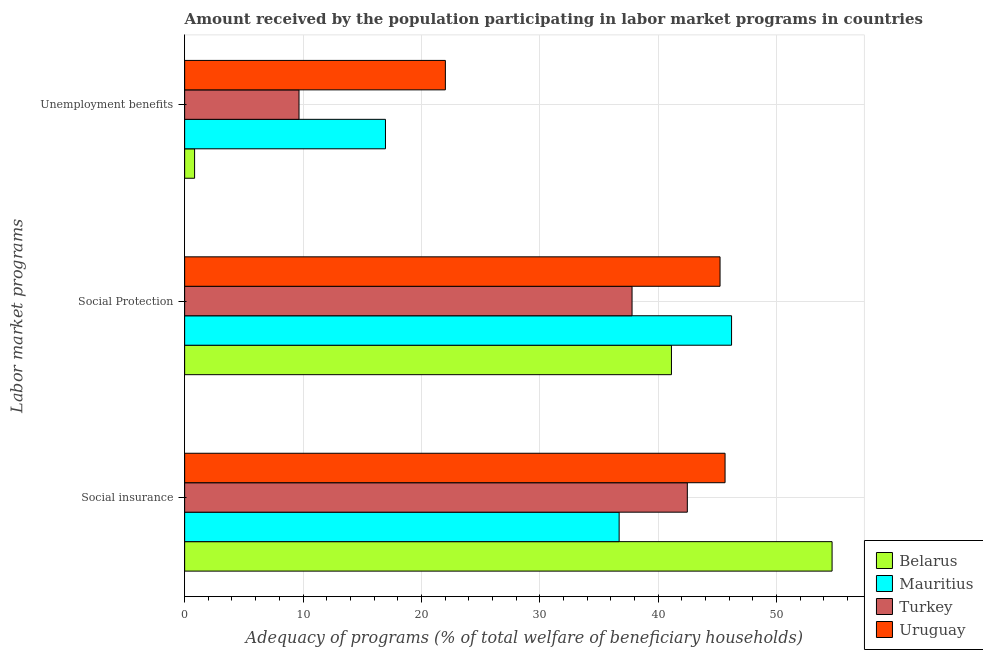How many different coloured bars are there?
Provide a short and direct response. 4. How many groups of bars are there?
Offer a terse response. 3. How many bars are there on the 3rd tick from the top?
Provide a short and direct response. 4. How many bars are there on the 3rd tick from the bottom?
Provide a short and direct response. 4. What is the label of the 3rd group of bars from the top?
Offer a very short reply. Social insurance. What is the amount received by the population participating in social protection programs in Turkey?
Give a very brief answer. 37.8. Across all countries, what is the maximum amount received by the population participating in unemployment benefits programs?
Your answer should be very brief. 22.03. Across all countries, what is the minimum amount received by the population participating in unemployment benefits programs?
Provide a short and direct response. 0.84. In which country was the amount received by the population participating in social insurance programs maximum?
Your response must be concise. Belarus. In which country was the amount received by the population participating in social insurance programs minimum?
Offer a terse response. Mauritius. What is the total amount received by the population participating in unemployment benefits programs in the graph?
Ensure brevity in your answer.  49.5. What is the difference between the amount received by the population participating in social insurance programs in Uruguay and that in Mauritius?
Provide a short and direct response. 8.95. What is the difference between the amount received by the population participating in social protection programs in Mauritius and the amount received by the population participating in unemployment benefits programs in Turkey?
Make the answer very short. 36.54. What is the average amount received by the population participating in social protection programs per country?
Make the answer very short. 42.59. What is the difference between the amount received by the population participating in social insurance programs and amount received by the population participating in unemployment benefits programs in Belarus?
Keep it short and to the point. 53.86. What is the ratio of the amount received by the population participating in social insurance programs in Turkey to that in Uruguay?
Make the answer very short. 0.93. Is the amount received by the population participating in unemployment benefits programs in Uruguay less than that in Turkey?
Your response must be concise. No. What is the difference between the highest and the second highest amount received by the population participating in social protection programs?
Provide a short and direct response. 0.97. What is the difference between the highest and the lowest amount received by the population participating in social protection programs?
Keep it short and to the point. 8.41. Is the sum of the amount received by the population participating in social insurance programs in Turkey and Uruguay greater than the maximum amount received by the population participating in social protection programs across all countries?
Offer a very short reply. Yes. What does the 1st bar from the top in Unemployment benefits represents?
Ensure brevity in your answer.  Uruguay. What does the 4th bar from the bottom in Social insurance represents?
Make the answer very short. Uruguay. Is it the case that in every country, the sum of the amount received by the population participating in social insurance programs and amount received by the population participating in social protection programs is greater than the amount received by the population participating in unemployment benefits programs?
Your answer should be very brief. Yes. What is the difference between two consecutive major ticks on the X-axis?
Your response must be concise. 10. Does the graph contain any zero values?
Provide a succinct answer. No. How are the legend labels stacked?
Offer a very short reply. Vertical. What is the title of the graph?
Make the answer very short. Amount received by the population participating in labor market programs in countries. Does "Armenia" appear as one of the legend labels in the graph?
Ensure brevity in your answer.  No. What is the label or title of the X-axis?
Your answer should be compact. Adequacy of programs (% of total welfare of beneficiary households). What is the label or title of the Y-axis?
Your response must be concise. Labor market programs. What is the Adequacy of programs (% of total welfare of beneficiary households) of Belarus in Social insurance?
Provide a succinct answer. 54.7. What is the Adequacy of programs (% of total welfare of beneficiary households) of Mauritius in Social insurance?
Offer a very short reply. 36.71. What is the Adequacy of programs (% of total welfare of beneficiary households) in Turkey in Social insurance?
Give a very brief answer. 42.47. What is the Adequacy of programs (% of total welfare of beneficiary households) in Uruguay in Social insurance?
Offer a very short reply. 45.66. What is the Adequacy of programs (% of total welfare of beneficiary households) of Belarus in Social Protection?
Offer a terse response. 41.13. What is the Adequacy of programs (% of total welfare of beneficiary households) of Mauritius in Social Protection?
Your response must be concise. 46.21. What is the Adequacy of programs (% of total welfare of beneficiary households) of Turkey in Social Protection?
Your response must be concise. 37.8. What is the Adequacy of programs (% of total welfare of beneficiary households) of Uruguay in Social Protection?
Offer a terse response. 45.24. What is the Adequacy of programs (% of total welfare of beneficiary households) in Belarus in Unemployment benefits?
Make the answer very short. 0.84. What is the Adequacy of programs (% of total welfare of beneficiary households) of Mauritius in Unemployment benefits?
Your answer should be very brief. 16.97. What is the Adequacy of programs (% of total welfare of beneficiary households) in Turkey in Unemployment benefits?
Keep it short and to the point. 9.66. What is the Adequacy of programs (% of total welfare of beneficiary households) in Uruguay in Unemployment benefits?
Ensure brevity in your answer.  22.03. Across all Labor market programs, what is the maximum Adequacy of programs (% of total welfare of beneficiary households) of Belarus?
Offer a very short reply. 54.7. Across all Labor market programs, what is the maximum Adequacy of programs (% of total welfare of beneficiary households) of Mauritius?
Give a very brief answer. 46.21. Across all Labor market programs, what is the maximum Adequacy of programs (% of total welfare of beneficiary households) in Turkey?
Offer a very short reply. 42.47. Across all Labor market programs, what is the maximum Adequacy of programs (% of total welfare of beneficiary households) in Uruguay?
Your response must be concise. 45.66. Across all Labor market programs, what is the minimum Adequacy of programs (% of total welfare of beneficiary households) in Belarus?
Provide a succinct answer. 0.84. Across all Labor market programs, what is the minimum Adequacy of programs (% of total welfare of beneficiary households) in Mauritius?
Give a very brief answer. 16.97. Across all Labor market programs, what is the minimum Adequacy of programs (% of total welfare of beneficiary households) of Turkey?
Your response must be concise. 9.66. Across all Labor market programs, what is the minimum Adequacy of programs (% of total welfare of beneficiary households) of Uruguay?
Ensure brevity in your answer.  22.03. What is the total Adequacy of programs (% of total welfare of beneficiary households) in Belarus in the graph?
Your answer should be very brief. 96.67. What is the total Adequacy of programs (% of total welfare of beneficiary households) in Mauritius in the graph?
Give a very brief answer. 99.89. What is the total Adequacy of programs (% of total welfare of beneficiary households) in Turkey in the graph?
Your response must be concise. 89.93. What is the total Adequacy of programs (% of total welfare of beneficiary households) of Uruguay in the graph?
Provide a short and direct response. 112.92. What is the difference between the Adequacy of programs (% of total welfare of beneficiary households) of Belarus in Social insurance and that in Social Protection?
Your answer should be compact. 13.57. What is the difference between the Adequacy of programs (% of total welfare of beneficiary households) in Mauritius in Social insurance and that in Social Protection?
Provide a succinct answer. -9.5. What is the difference between the Adequacy of programs (% of total welfare of beneficiary households) in Turkey in Social insurance and that in Social Protection?
Keep it short and to the point. 4.67. What is the difference between the Adequacy of programs (% of total welfare of beneficiary households) in Uruguay in Social insurance and that in Social Protection?
Provide a short and direct response. 0.42. What is the difference between the Adequacy of programs (% of total welfare of beneficiary households) in Belarus in Social insurance and that in Unemployment benefits?
Provide a short and direct response. 53.86. What is the difference between the Adequacy of programs (% of total welfare of beneficiary households) in Mauritius in Social insurance and that in Unemployment benefits?
Offer a terse response. 19.74. What is the difference between the Adequacy of programs (% of total welfare of beneficiary households) of Turkey in Social insurance and that in Unemployment benefits?
Your answer should be very brief. 32.81. What is the difference between the Adequacy of programs (% of total welfare of beneficiary households) of Uruguay in Social insurance and that in Unemployment benefits?
Make the answer very short. 23.63. What is the difference between the Adequacy of programs (% of total welfare of beneficiary households) in Belarus in Social Protection and that in Unemployment benefits?
Offer a very short reply. 40.29. What is the difference between the Adequacy of programs (% of total welfare of beneficiary households) of Mauritius in Social Protection and that in Unemployment benefits?
Offer a very short reply. 29.24. What is the difference between the Adequacy of programs (% of total welfare of beneficiary households) of Turkey in Social Protection and that in Unemployment benefits?
Your response must be concise. 28.14. What is the difference between the Adequacy of programs (% of total welfare of beneficiary households) in Uruguay in Social Protection and that in Unemployment benefits?
Your answer should be very brief. 23.21. What is the difference between the Adequacy of programs (% of total welfare of beneficiary households) in Belarus in Social insurance and the Adequacy of programs (% of total welfare of beneficiary households) in Mauritius in Social Protection?
Your answer should be very brief. 8.49. What is the difference between the Adequacy of programs (% of total welfare of beneficiary households) of Belarus in Social insurance and the Adequacy of programs (% of total welfare of beneficiary households) of Uruguay in Social Protection?
Provide a short and direct response. 9.46. What is the difference between the Adequacy of programs (% of total welfare of beneficiary households) in Mauritius in Social insurance and the Adequacy of programs (% of total welfare of beneficiary households) in Turkey in Social Protection?
Your answer should be very brief. -1.09. What is the difference between the Adequacy of programs (% of total welfare of beneficiary households) of Mauritius in Social insurance and the Adequacy of programs (% of total welfare of beneficiary households) of Uruguay in Social Protection?
Your response must be concise. -8.52. What is the difference between the Adequacy of programs (% of total welfare of beneficiary households) in Turkey in Social insurance and the Adequacy of programs (% of total welfare of beneficiary households) in Uruguay in Social Protection?
Your answer should be compact. -2.76. What is the difference between the Adequacy of programs (% of total welfare of beneficiary households) of Belarus in Social insurance and the Adequacy of programs (% of total welfare of beneficiary households) of Mauritius in Unemployment benefits?
Keep it short and to the point. 37.73. What is the difference between the Adequacy of programs (% of total welfare of beneficiary households) of Belarus in Social insurance and the Adequacy of programs (% of total welfare of beneficiary households) of Turkey in Unemployment benefits?
Your answer should be compact. 45.04. What is the difference between the Adequacy of programs (% of total welfare of beneficiary households) in Belarus in Social insurance and the Adequacy of programs (% of total welfare of beneficiary households) in Uruguay in Unemployment benefits?
Offer a very short reply. 32.67. What is the difference between the Adequacy of programs (% of total welfare of beneficiary households) of Mauritius in Social insurance and the Adequacy of programs (% of total welfare of beneficiary households) of Turkey in Unemployment benefits?
Your answer should be compact. 27.05. What is the difference between the Adequacy of programs (% of total welfare of beneficiary households) in Mauritius in Social insurance and the Adequacy of programs (% of total welfare of beneficiary households) in Uruguay in Unemployment benefits?
Provide a short and direct response. 14.68. What is the difference between the Adequacy of programs (% of total welfare of beneficiary households) in Turkey in Social insurance and the Adequacy of programs (% of total welfare of beneficiary households) in Uruguay in Unemployment benefits?
Keep it short and to the point. 20.44. What is the difference between the Adequacy of programs (% of total welfare of beneficiary households) in Belarus in Social Protection and the Adequacy of programs (% of total welfare of beneficiary households) in Mauritius in Unemployment benefits?
Your answer should be compact. 24.16. What is the difference between the Adequacy of programs (% of total welfare of beneficiary households) in Belarus in Social Protection and the Adequacy of programs (% of total welfare of beneficiary households) in Turkey in Unemployment benefits?
Offer a terse response. 31.47. What is the difference between the Adequacy of programs (% of total welfare of beneficiary households) in Belarus in Social Protection and the Adequacy of programs (% of total welfare of beneficiary households) in Uruguay in Unemployment benefits?
Make the answer very short. 19.1. What is the difference between the Adequacy of programs (% of total welfare of beneficiary households) in Mauritius in Social Protection and the Adequacy of programs (% of total welfare of beneficiary households) in Turkey in Unemployment benefits?
Give a very brief answer. 36.54. What is the difference between the Adequacy of programs (% of total welfare of beneficiary households) in Mauritius in Social Protection and the Adequacy of programs (% of total welfare of beneficiary households) in Uruguay in Unemployment benefits?
Your answer should be compact. 24.18. What is the difference between the Adequacy of programs (% of total welfare of beneficiary households) of Turkey in Social Protection and the Adequacy of programs (% of total welfare of beneficiary households) of Uruguay in Unemployment benefits?
Provide a succinct answer. 15.77. What is the average Adequacy of programs (% of total welfare of beneficiary households) of Belarus per Labor market programs?
Offer a very short reply. 32.22. What is the average Adequacy of programs (% of total welfare of beneficiary households) of Mauritius per Labor market programs?
Your answer should be compact. 33.3. What is the average Adequacy of programs (% of total welfare of beneficiary households) of Turkey per Labor market programs?
Ensure brevity in your answer.  29.98. What is the average Adequacy of programs (% of total welfare of beneficiary households) of Uruguay per Labor market programs?
Offer a terse response. 37.64. What is the difference between the Adequacy of programs (% of total welfare of beneficiary households) of Belarus and Adequacy of programs (% of total welfare of beneficiary households) of Mauritius in Social insurance?
Ensure brevity in your answer.  17.99. What is the difference between the Adequacy of programs (% of total welfare of beneficiary households) of Belarus and Adequacy of programs (% of total welfare of beneficiary households) of Turkey in Social insurance?
Make the answer very short. 12.23. What is the difference between the Adequacy of programs (% of total welfare of beneficiary households) of Belarus and Adequacy of programs (% of total welfare of beneficiary households) of Uruguay in Social insurance?
Make the answer very short. 9.04. What is the difference between the Adequacy of programs (% of total welfare of beneficiary households) in Mauritius and Adequacy of programs (% of total welfare of beneficiary households) in Turkey in Social insurance?
Give a very brief answer. -5.76. What is the difference between the Adequacy of programs (% of total welfare of beneficiary households) in Mauritius and Adequacy of programs (% of total welfare of beneficiary households) in Uruguay in Social insurance?
Provide a succinct answer. -8.95. What is the difference between the Adequacy of programs (% of total welfare of beneficiary households) of Turkey and Adequacy of programs (% of total welfare of beneficiary households) of Uruguay in Social insurance?
Make the answer very short. -3.19. What is the difference between the Adequacy of programs (% of total welfare of beneficiary households) in Belarus and Adequacy of programs (% of total welfare of beneficiary households) in Mauritius in Social Protection?
Your response must be concise. -5.08. What is the difference between the Adequacy of programs (% of total welfare of beneficiary households) in Belarus and Adequacy of programs (% of total welfare of beneficiary households) in Turkey in Social Protection?
Offer a terse response. 3.33. What is the difference between the Adequacy of programs (% of total welfare of beneficiary households) in Belarus and Adequacy of programs (% of total welfare of beneficiary households) in Uruguay in Social Protection?
Offer a terse response. -4.11. What is the difference between the Adequacy of programs (% of total welfare of beneficiary households) in Mauritius and Adequacy of programs (% of total welfare of beneficiary households) in Turkey in Social Protection?
Make the answer very short. 8.41. What is the difference between the Adequacy of programs (% of total welfare of beneficiary households) in Mauritius and Adequacy of programs (% of total welfare of beneficiary households) in Uruguay in Social Protection?
Your answer should be very brief. 0.97. What is the difference between the Adequacy of programs (% of total welfare of beneficiary households) in Turkey and Adequacy of programs (% of total welfare of beneficiary households) in Uruguay in Social Protection?
Make the answer very short. -7.44. What is the difference between the Adequacy of programs (% of total welfare of beneficiary households) of Belarus and Adequacy of programs (% of total welfare of beneficiary households) of Mauritius in Unemployment benefits?
Offer a terse response. -16.13. What is the difference between the Adequacy of programs (% of total welfare of beneficiary households) in Belarus and Adequacy of programs (% of total welfare of beneficiary households) in Turkey in Unemployment benefits?
Offer a terse response. -8.82. What is the difference between the Adequacy of programs (% of total welfare of beneficiary households) in Belarus and Adequacy of programs (% of total welfare of beneficiary households) in Uruguay in Unemployment benefits?
Offer a terse response. -21.19. What is the difference between the Adequacy of programs (% of total welfare of beneficiary households) of Mauritius and Adequacy of programs (% of total welfare of beneficiary households) of Turkey in Unemployment benefits?
Your answer should be compact. 7.3. What is the difference between the Adequacy of programs (% of total welfare of beneficiary households) in Mauritius and Adequacy of programs (% of total welfare of beneficiary households) in Uruguay in Unemployment benefits?
Your response must be concise. -5.06. What is the difference between the Adequacy of programs (% of total welfare of beneficiary households) in Turkey and Adequacy of programs (% of total welfare of beneficiary households) in Uruguay in Unemployment benefits?
Give a very brief answer. -12.37. What is the ratio of the Adequacy of programs (% of total welfare of beneficiary households) of Belarus in Social insurance to that in Social Protection?
Keep it short and to the point. 1.33. What is the ratio of the Adequacy of programs (% of total welfare of beneficiary households) of Mauritius in Social insurance to that in Social Protection?
Your answer should be compact. 0.79. What is the ratio of the Adequacy of programs (% of total welfare of beneficiary households) in Turkey in Social insurance to that in Social Protection?
Keep it short and to the point. 1.12. What is the ratio of the Adequacy of programs (% of total welfare of beneficiary households) of Uruguay in Social insurance to that in Social Protection?
Your response must be concise. 1.01. What is the ratio of the Adequacy of programs (% of total welfare of beneficiary households) in Belarus in Social insurance to that in Unemployment benefits?
Give a very brief answer. 65. What is the ratio of the Adequacy of programs (% of total welfare of beneficiary households) in Mauritius in Social insurance to that in Unemployment benefits?
Ensure brevity in your answer.  2.16. What is the ratio of the Adequacy of programs (% of total welfare of beneficiary households) of Turkey in Social insurance to that in Unemployment benefits?
Give a very brief answer. 4.39. What is the ratio of the Adequacy of programs (% of total welfare of beneficiary households) in Uruguay in Social insurance to that in Unemployment benefits?
Your response must be concise. 2.07. What is the ratio of the Adequacy of programs (% of total welfare of beneficiary households) of Belarus in Social Protection to that in Unemployment benefits?
Offer a very short reply. 48.88. What is the ratio of the Adequacy of programs (% of total welfare of beneficiary households) in Mauritius in Social Protection to that in Unemployment benefits?
Ensure brevity in your answer.  2.72. What is the ratio of the Adequacy of programs (% of total welfare of beneficiary households) of Turkey in Social Protection to that in Unemployment benefits?
Ensure brevity in your answer.  3.91. What is the ratio of the Adequacy of programs (% of total welfare of beneficiary households) of Uruguay in Social Protection to that in Unemployment benefits?
Provide a short and direct response. 2.05. What is the difference between the highest and the second highest Adequacy of programs (% of total welfare of beneficiary households) in Belarus?
Provide a short and direct response. 13.57. What is the difference between the highest and the second highest Adequacy of programs (% of total welfare of beneficiary households) in Mauritius?
Provide a short and direct response. 9.5. What is the difference between the highest and the second highest Adequacy of programs (% of total welfare of beneficiary households) of Turkey?
Offer a very short reply. 4.67. What is the difference between the highest and the second highest Adequacy of programs (% of total welfare of beneficiary households) of Uruguay?
Provide a succinct answer. 0.42. What is the difference between the highest and the lowest Adequacy of programs (% of total welfare of beneficiary households) of Belarus?
Your answer should be compact. 53.86. What is the difference between the highest and the lowest Adequacy of programs (% of total welfare of beneficiary households) of Mauritius?
Your answer should be very brief. 29.24. What is the difference between the highest and the lowest Adequacy of programs (% of total welfare of beneficiary households) in Turkey?
Keep it short and to the point. 32.81. What is the difference between the highest and the lowest Adequacy of programs (% of total welfare of beneficiary households) in Uruguay?
Ensure brevity in your answer.  23.63. 